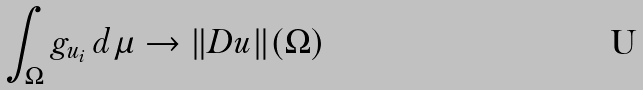Convert formula to latex. <formula><loc_0><loc_0><loc_500><loc_500>\int _ { \Omega } g _ { u _ { i } } \, d \mu \to \| D u \| ( \Omega )</formula> 